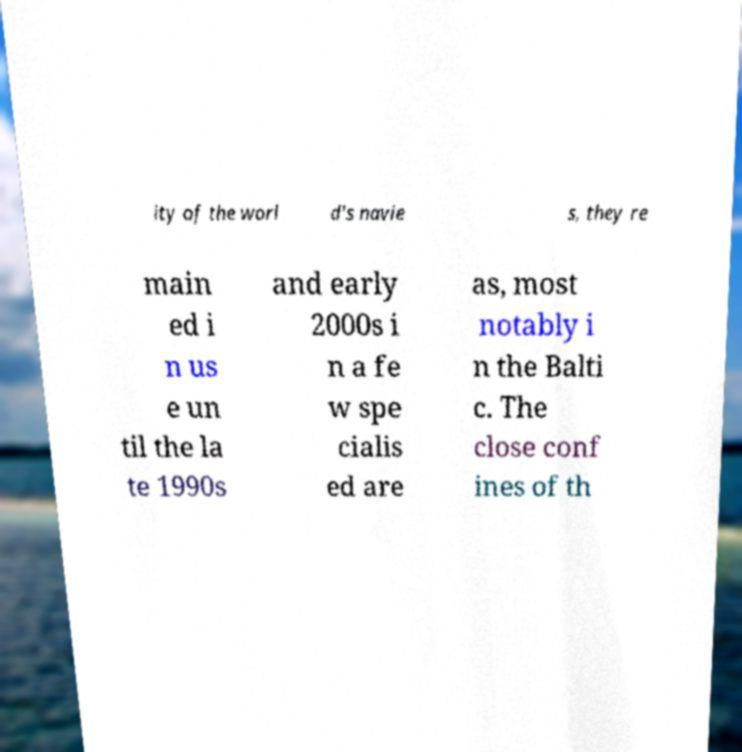Please identify and transcribe the text found in this image. ity of the worl d's navie s, they re main ed i n us e un til the la te 1990s and early 2000s i n a fe w spe cialis ed are as, most notably i n the Balti c. The close conf ines of th 